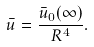<formula> <loc_0><loc_0><loc_500><loc_500>\bar { u } = \frac { \bar { u } _ { 0 } ( \infty ) } { R ^ { 4 } } .</formula> 